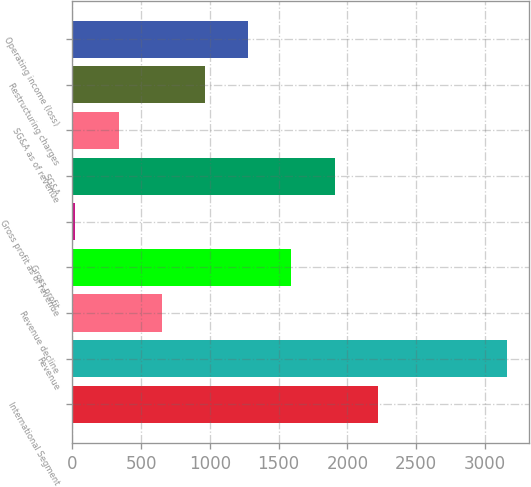<chart> <loc_0><loc_0><loc_500><loc_500><bar_chart><fcel>International Segment<fcel>Revenue<fcel>Revenue decline<fcel>Gross profit<fcel>Gross profit as of revenue<fcel>SG&A<fcel>SG&A as of revenue<fcel>Restructuring charges<fcel>Operating income (loss)<nl><fcel>2220.82<fcel>3163<fcel>650.52<fcel>1592.7<fcel>22.4<fcel>1906.76<fcel>336.46<fcel>964.58<fcel>1278.64<nl></chart> 